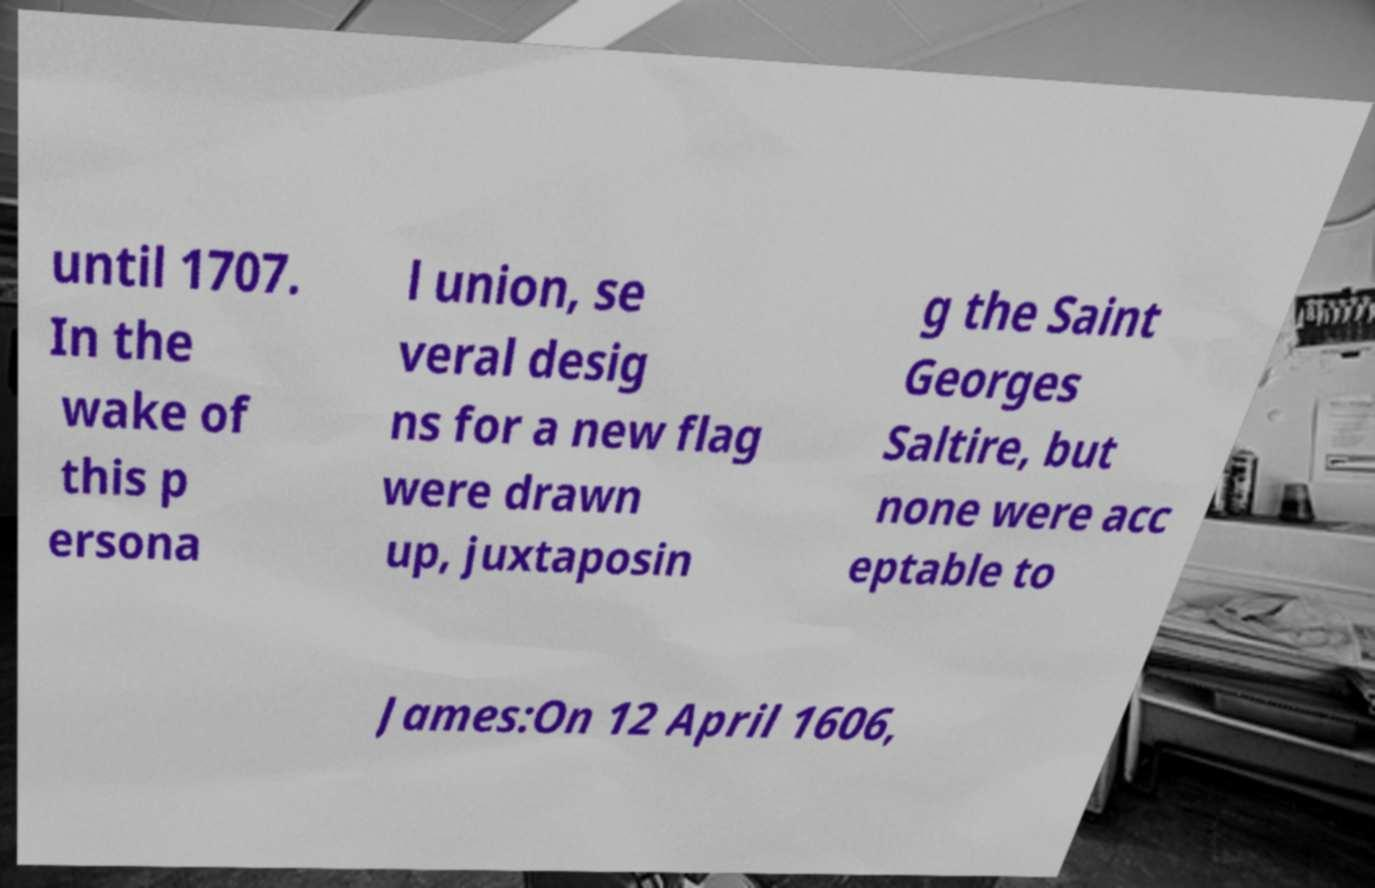Please read and relay the text visible in this image. What does it say? until 1707. In the wake of this p ersona l union, se veral desig ns for a new flag were drawn up, juxtaposin g the Saint Georges Saltire, but none were acc eptable to James:On 12 April 1606, 